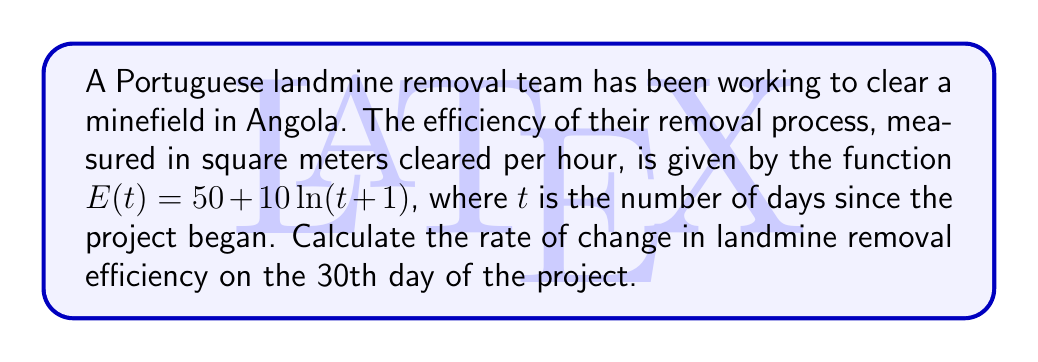Can you solve this math problem? To solve this problem, we need to follow these steps:

1) The efficiency function is given as:
   $E(t) = 50 + 10\ln(t+1)$

2) To find the rate of change in efficiency, we need to calculate the derivative of $E(t)$ with respect to $t$:
   $$\frac{dE}{dt} = \frac{d}{dt}[50 + 10\ln(t+1)]$$

3) Using the chain rule and the derivative of the natural logarithm:
   $$\frac{dE}{dt} = 0 + 10 \cdot \frac{1}{t+1} \cdot \frac{d}{dt}(t+1)$$
   $$\frac{dE}{dt} = \frac{10}{t+1}$$

4) Now, we need to evaluate this at $t = 30$ (the 30th day):
   $$\left.\frac{dE}{dt}\right|_{t=30} = \frac{10}{30+1} = \frac{10}{31}$$

5) Simplify the fraction:
   $$\frac{10}{31} \approx 0.3226$$

Therefore, on the 30th day, the rate of change in landmine removal efficiency is approximately 0.3226 square meters per hour per day.
Answer: $\frac{10}{31}$ sq m/hr/day 